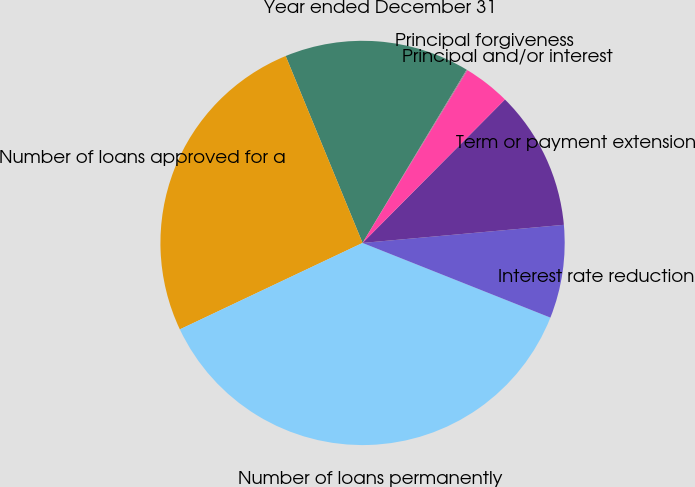<chart> <loc_0><loc_0><loc_500><loc_500><pie_chart><fcel>Year ended December 31<fcel>Number of loans approved for a<fcel>Number of loans permanently<fcel>Interest rate reduction<fcel>Term or payment extension<fcel>Principal and/or interest<fcel>Principal forgiveness<nl><fcel>14.82%<fcel>25.82%<fcel>36.94%<fcel>7.45%<fcel>11.13%<fcel>3.76%<fcel>0.07%<nl></chart> 